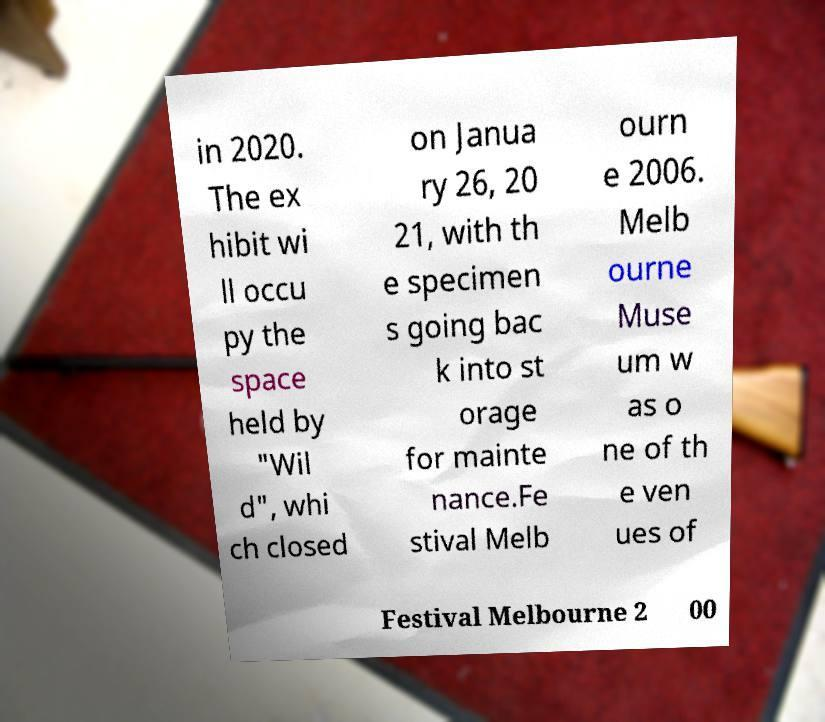Could you assist in decoding the text presented in this image and type it out clearly? in 2020. The ex hibit wi ll occu py the space held by "Wil d", whi ch closed on Janua ry 26, 20 21, with th e specimen s going bac k into st orage for mainte nance.Fe stival Melb ourn e 2006. Melb ourne Muse um w as o ne of th e ven ues of Festival Melbourne 2 00 